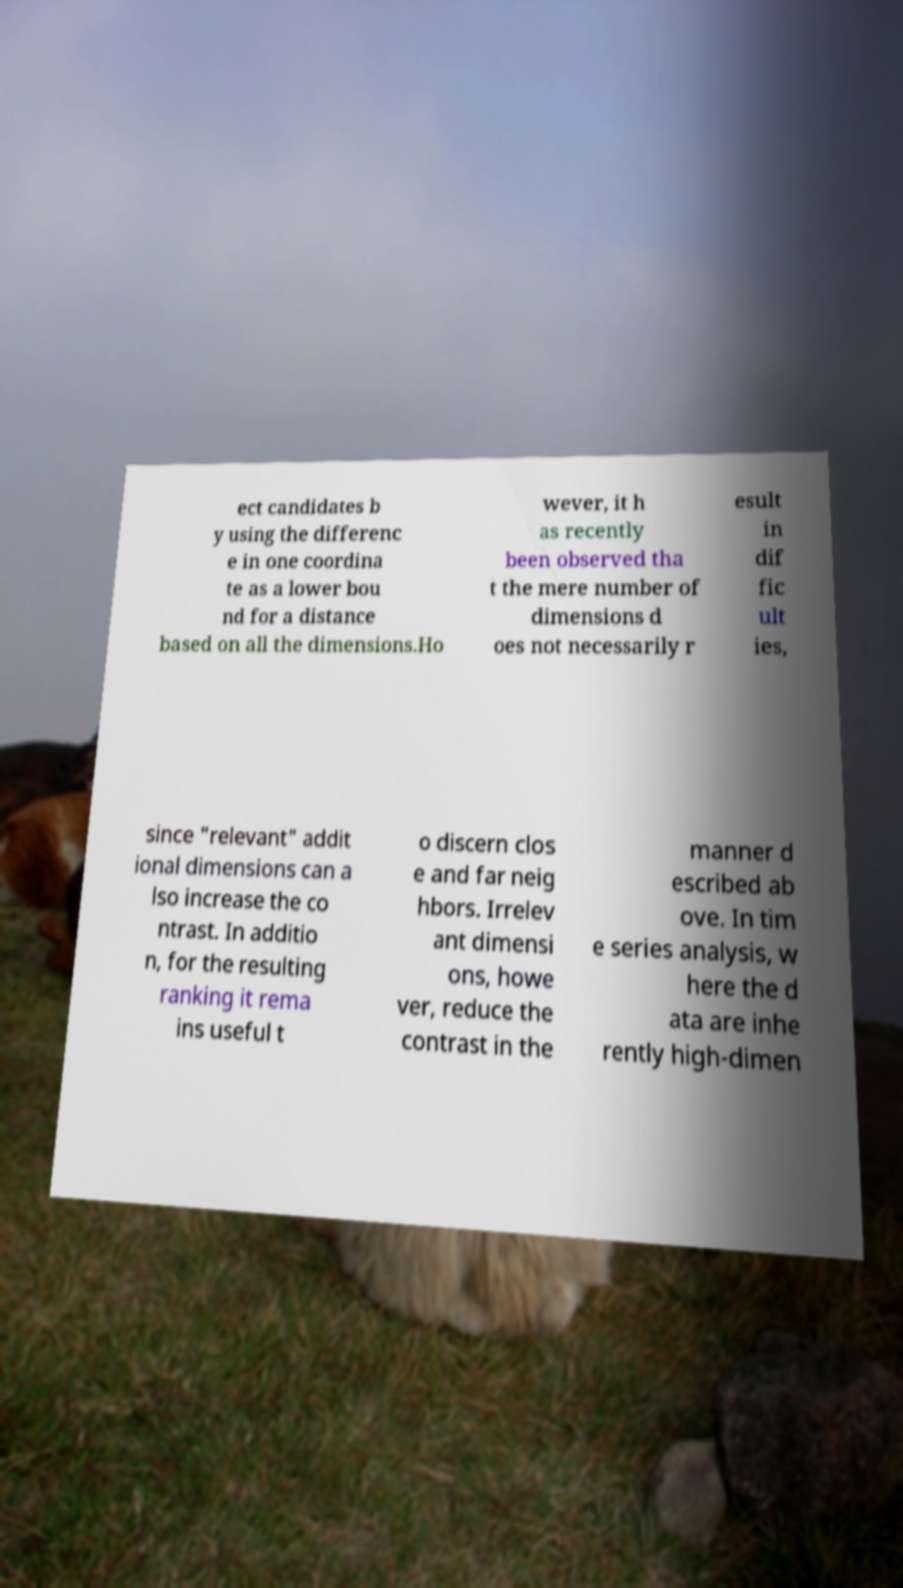Please identify and transcribe the text found in this image. ect candidates b y using the differenc e in one coordina te as a lower bou nd for a distance based on all the dimensions.Ho wever, it h as recently been observed tha t the mere number of dimensions d oes not necessarily r esult in dif fic ult ies, since "relevant" addit ional dimensions can a lso increase the co ntrast. In additio n, for the resulting ranking it rema ins useful t o discern clos e and far neig hbors. Irrelev ant dimensi ons, howe ver, reduce the contrast in the manner d escribed ab ove. In tim e series analysis, w here the d ata are inhe rently high-dimen 